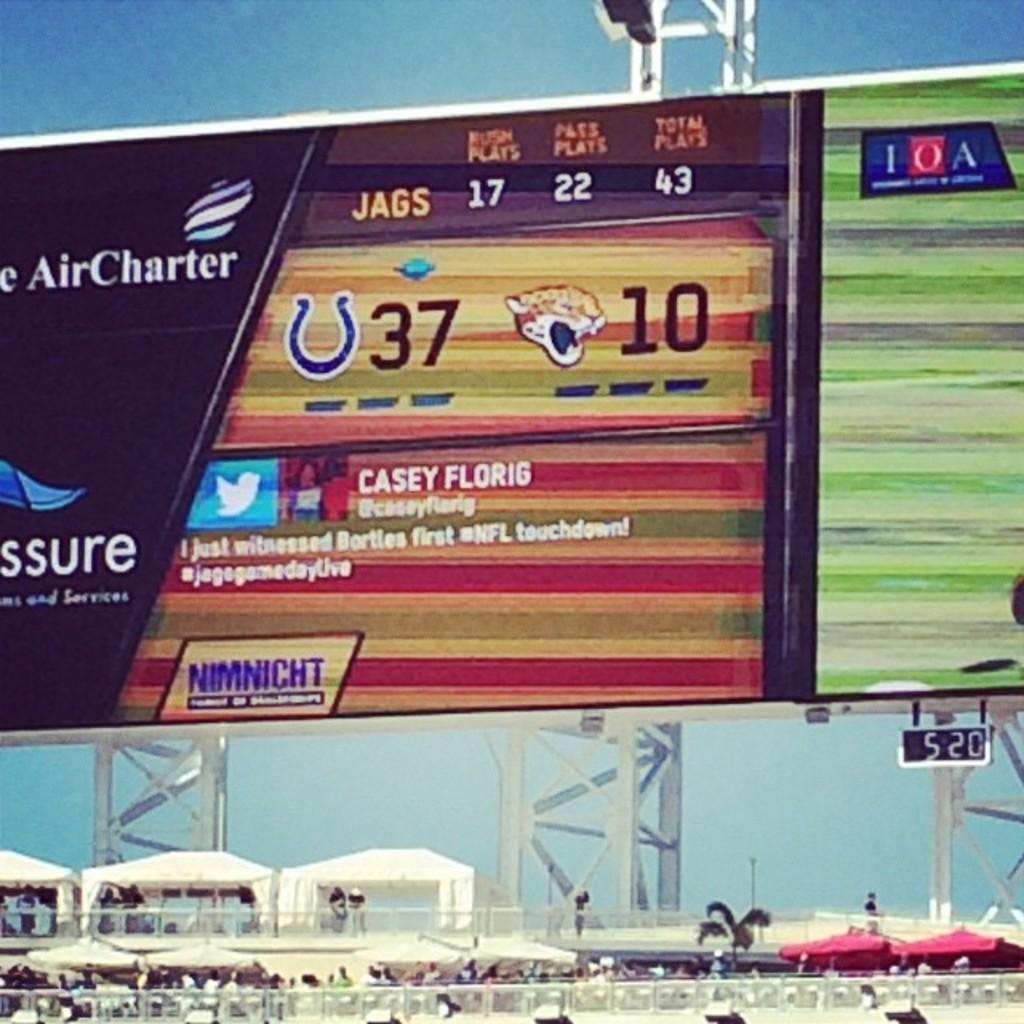<image>
Present a compact description of the photo's key features. A jumbotron in a sports stadium showing the Jags team is losing by 27 points. 